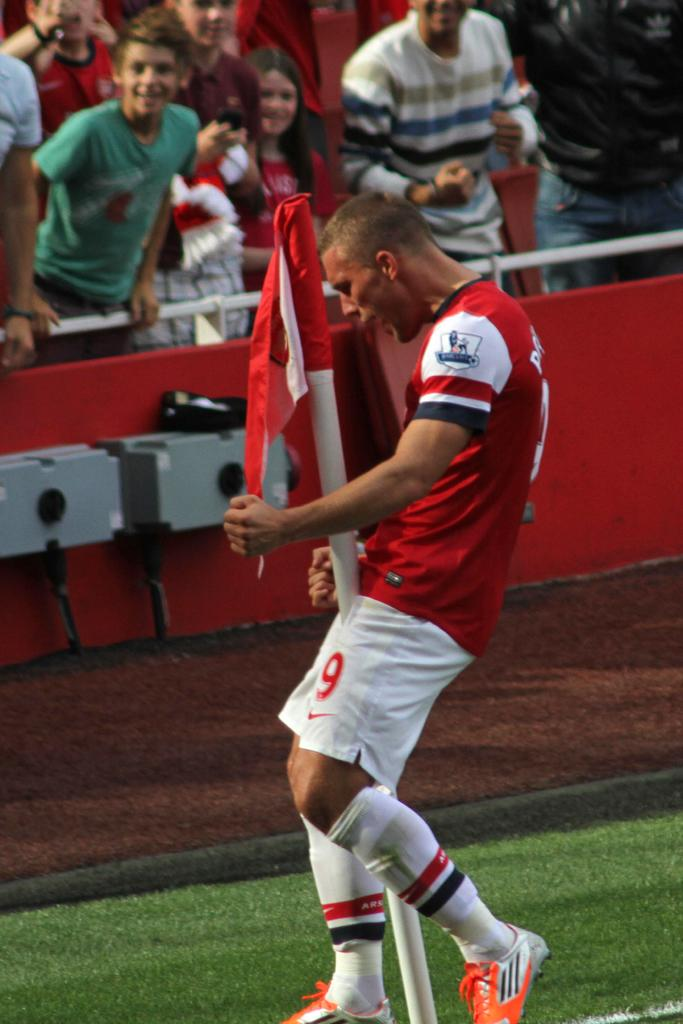<image>
Share a concise interpretation of the image provided. a player with the number 9 on their shorts 